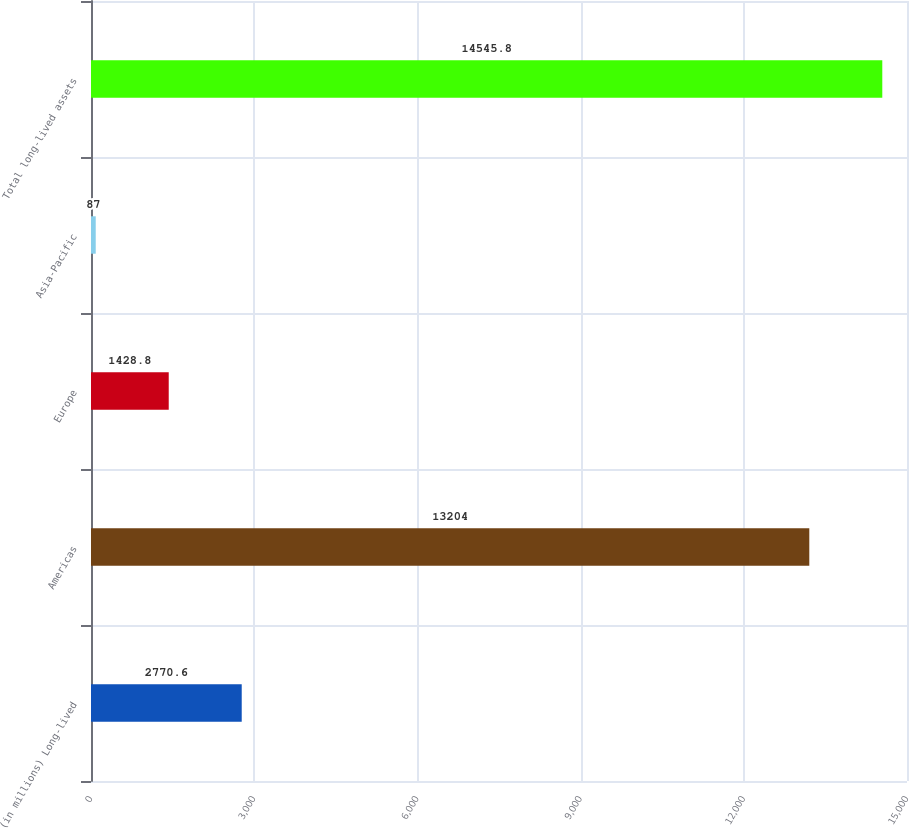<chart> <loc_0><loc_0><loc_500><loc_500><bar_chart><fcel>(in millions) Long-lived<fcel>Americas<fcel>Europe<fcel>Asia-Pacific<fcel>Total long-lived assets<nl><fcel>2770.6<fcel>13204<fcel>1428.8<fcel>87<fcel>14545.8<nl></chart> 